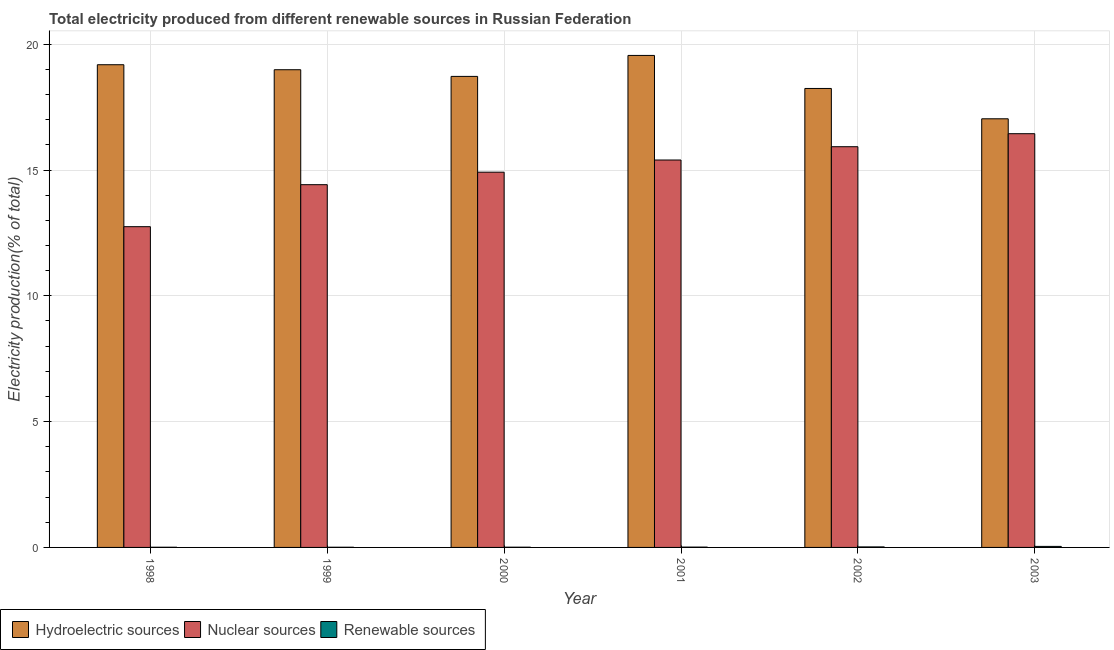How many different coloured bars are there?
Your answer should be very brief. 3. Are the number of bars per tick equal to the number of legend labels?
Your answer should be compact. Yes. How many bars are there on the 6th tick from the left?
Offer a terse response. 3. How many bars are there on the 2nd tick from the right?
Ensure brevity in your answer.  3. What is the percentage of electricity produced by renewable sources in 1999?
Your answer should be compact. 0.01. Across all years, what is the maximum percentage of electricity produced by renewable sources?
Your answer should be very brief. 0.04. Across all years, what is the minimum percentage of electricity produced by nuclear sources?
Ensure brevity in your answer.  12.75. What is the total percentage of electricity produced by hydroelectric sources in the graph?
Give a very brief answer. 111.72. What is the difference between the percentage of electricity produced by nuclear sources in 1998 and that in 2000?
Provide a succinct answer. -2.17. What is the difference between the percentage of electricity produced by renewable sources in 2003 and the percentage of electricity produced by hydroelectric sources in 1998?
Your answer should be compact. 0.03. What is the average percentage of electricity produced by renewable sources per year?
Ensure brevity in your answer.  0.02. In the year 1998, what is the difference between the percentage of electricity produced by nuclear sources and percentage of electricity produced by hydroelectric sources?
Ensure brevity in your answer.  0. In how many years, is the percentage of electricity produced by hydroelectric sources greater than 17 %?
Your answer should be very brief. 6. What is the ratio of the percentage of electricity produced by renewable sources in 1998 to that in 2000?
Make the answer very short. 0.75. What is the difference between the highest and the second highest percentage of electricity produced by hydroelectric sources?
Offer a terse response. 0.37. What is the difference between the highest and the lowest percentage of electricity produced by renewable sources?
Ensure brevity in your answer.  0.03. Is the sum of the percentage of electricity produced by hydroelectric sources in 2001 and 2003 greater than the maximum percentage of electricity produced by renewable sources across all years?
Make the answer very short. Yes. What does the 2nd bar from the left in 2001 represents?
Your response must be concise. Nuclear sources. What does the 1st bar from the right in 2001 represents?
Offer a terse response. Renewable sources. Is it the case that in every year, the sum of the percentage of electricity produced by hydroelectric sources and percentage of electricity produced by nuclear sources is greater than the percentage of electricity produced by renewable sources?
Provide a succinct answer. Yes. Are all the bars in the graph horizontal?
Make the answer very short. No. How many years are there in the graph?
Your answer should be compact. 6. Are the values on the major ticks of Y-axis written in scientific E-notation?
Your answer should be very brief. No. Does the graph contain any zero values?
Your answer should be very brief. No. Does the graph contain grids?
Your answer should be compact. Yes. How many legend labels are there?
Ensure brevity in your answer.  3. How are the legend labels stacked?
Make the answer very short. Horizontal. What is the title of the graph?
Your response must be concise. Total electricity produced from different renewable sources in Russian Federation. Does "Infant(male)" appear as one of the legend labels in the graph?
Keep it short and to the point. No. What is the label or title of the Y-axis?
Give a very brief answer. Electricity production(% of total). What is the Electricity production(% of total) of Hydroelectric sources in 1998?
Make the answer very short. 19.18. What is the Electricity production(% of total) of Nuclear sources in 1998?
Offer a terse response. 12.75. What is the Electricity production(% of total) of Renewable sources in 1998?
Your answer should be very brief. 0.01. What is the Electricity production(% of total) of Hydroelectric sources in 1999?
Your answer should be very brief. 18.99. What is the Electricity production(% of total) in Nuclear sources in 1999?
Give a very brief answer. 14.42. What is the Electricity production(% of total) in Renewable sources in 1999?
Give a very brief answer. 0.01. What is the Electricity production(% of total) of Hydroelectric sources in 2000?
Keep it short and to the point. 18.72. What is the Electricity production(% of total) in Nuclear sources in 2000?
Provide a short and direct response. 14.91. What is the Electricity production(% of total) of Renewable sources in 2000?
Ensure brevity in your answer.  0.01. What is the Electricity production(% of total) in Hydroelectric sources in 2001?
Offer a very short reply. 19.55. What is the Electricity production(% of total) of Nuclear sources in 2001?
Ensure brevity in your answer.  15.4. What is the Electricity production(% of total) in Renewable sources in 2001?
Offer a very short reply. 0.01. What is the Electricity production(% of total) in Hydroelectric sources in 2002?
Offer a terse response. 18.24. What is the Electricity production(% of total) in Nuclear sources in 2002?
Offer a terse response. 15.93. What is the Electricity production(% of total) in Renewable sources in 2002?
Give a very brief answer. 0.02. What is the Electricity production(% of total) in Hydroelectric sources in 2003?
Keep it short and to the point. 17.04. What is the Electricity production(% of total) in Nuclear sources in 2003?
Offer a terse response. 16.44. What is the Electricity production(% of total) of Renewable sources in 2003?
Provide a short and direct response. 0.04. Across all years, what is the maximum Electricity production(% of total) of Hydroelectric sources?
Offer a terse response. 19.55. Across all years, what is the maximum Electricity production(% of total) in Nuclear sources?
Your answer should be compact. 16.44. Across all years, what is the maximum Electricity production(% of total) of Renewable sources?
Your answer should be very brief. 0.04. Across all years, what is the minimum Electricity production(% of total) of Hydroelectric sources?
Ensure brevity in your answer.  17.04. Across all years, what is the minimum Electricity production(% of total) of Nuclear sources?
Your response must be concise. 12.75. Across all years, what is the minimum Electricity production(% of total) in Renewable sources?
Provide a short and direct response. 0.01. What is the total Electricity production(% of total) of Hydroelectric sources in the graph?
Make the answer very short. 111.72. What is the total Electricity production(% of total) in Nuclear sources in the graph?
Provide a succinct answer. 89.84. What is the total Electricity production(% of total) of Renewable sources in the graph?
Make the answer very short. 0.1. What is the difference between the Electricity production(% of total) in Hydroelectric sources in 1998 and that in 1999?
Your answer should be very brief. 0.2. What is the difference between the Electricity production(% of total) of Nuclear sources in 1998 and that in 1999?
Offer a very short reply. -1.67. What is the difference between the Electricity production(% of total) of Renewable sources in 1998 and that in 1999?
Provide a short and direct response. -0. What is the difference between the Electricity production(% of total) of Hydroelectric sources in 1998 and that in 2000?
Keep it short and to the point. 0.46. What is the difference between the Electricity production(% of total) of Nuclear sources in 1998 and that in 2000?
Your answer should be compact. -2.17. What is the difference between the Electricity production(% of total) in Renewable sources in 1998 and that in 2000?
Provide a short and direct response. -0. What is the difference between the Electricity production(% of total) in Hydroelectric sources in 1998 and that in 2001?
Your response must be concise. -0.37. What is the difference between the Electricity production(% of total) in Nuclear sources in 1998 and that in 2001?
Give a very brief answer. -2.65. What is the difference between the Electricity production(% of total) of Renewable sources in 1998 and that in 2001?
Give a very brief answer. -0.01. What is the difference between the Electricity production(% of total) in Hydroelectric sources in 1998 and that in 2002?
Provide a succinct answer. 0.94. What is the difference between the Electricity production(% of total) of Nuclear sources in 1998 and that in 2002?
Ensure brevity in your answer.  -3.18. What is the difference between the Electricity production(% of total) of Renewable sources in 1998 and that in 2002?
Offer a terse response. -0.01. What is the difference between the Electricity production(% of total) in Hydroelectric sources in 1998 and that in 2003?
Your response must be concise. 2.15. What is the difference between the Electricity production(% of total) in Nuclear sources in 1998 and that in 2003?
Your answer should be compact. -3.7. What is the difference between the Electricity production(% of total) of Renewable sources in 1998 and that in 2003?
Your answer should be compact. -0.03. What is the difference between the Electricity production(% of total) in Hydroelectric sources in 1999 and that in 2000?
Offer a terse response. 0.27. What is the difference between the Electricity production(% of total) in Nuclear sources in 1999 and that in 2000?
Keep it short and to the point. -0.5. What is the difference between the Electricity production(% of total) of Renewable sources in 1999 and that in 2000?
Your answer should be very brief. -0. What is the difference between the Electricity production(% of total) in Hydroelectric sources in 1999 and that in 2001?
Your answer should be very brief. -0.57. What is the difference between the Electricity production(% of total) in Nuclear sources in 1999 and that in 2001?
Your answer should be very brief. -0.98. What is the difference between the Electricity production(% of total) of Renewable sources in 1999 and that in 2001?
Offer a very short reply. -0.01. What is the difference between the Electricity production(% of total) of Hydroelectric sources in 1999 and that in 2002?
Keep it short and to the point. 0.74. What is the difference between the Electricity production(% of total) in Nuclear sources in 1999 and that in 2002?
Provide a succinct answer. -1.51. What is the difference between the Electricity production(% of total) in Renewable sources in 1999 and that in 2002?
Your answer should be very brief. -0.01. What is the difference between the Electricity production(% of total) in Hydroelectric sources in 1999 and that in 2003?
Provide a succinct answer. 1.95. What is the difference between the Electricity production(% of total) in Nuclear sources in 1999 and that in 2003?
Make the answer very short. -2.03. What is the difference between the Electricity production(% of total) of Renewable sources in 1999 and that in 2003?
Ensure brevity in your answer.  -0.03. What is the difference between the Electricity production(% of total) in Hydroelectric sources in 2000 and that in 2001?
Your answer should be very brief. -0.83. What is the difference between the Electricity production(% of total) of Nuclear sources in 2000 and that in 2001?
Provide a succinct answer. -0.48. What is the difference between the Electricity production(% of total) of Renewable sources in 2000 and that in 2001?
Keep it short and to the point. -0. What is the difference between the Electricity production(% of total) in Hydroelectric sources in 2000 and that in 2002?
Provide a succinct answer. 0.48. What is the difference between the Electricity production(% of total) of Nuclear sources in 2000 and that in 2002?
Your answer should be very brief. -1.01. What is the difference between the Electricity production(% of total) in Renewable sources in 2000 and that in 2002?
Provide a succinct answer. -0.01. What is the difference between the Electricity production(% of total) in Hydroelectric sources in 2000 and that in 2003?
Provide a short and direct response. 1.68. What is the difference between the Electricity production(% of total) in Nuclear sources in 2000 and that in 2003?
Make the answer very short. -1.53. What is the difference between the Electricity production(% of total) in Renewable sources in 2000 and that in 2003?
Your answer should be very brief. -0.03. What is the difference between the Electricity production(% of total) in Hydroelectric sources in 2001 and that in 2002?
Provide a succinct answer. 1.31. What is the difference between the Electricity production(% of total) of Nuclear sources in 2001 and that in 2002?
Offer a very short reply. -0.53. What is the difference between the Electricity production(% of total) in Renewable sources in 2001 and that in 2002?
Your answer should be very brief. -0.01. What is the difference between the Electricity production(% of total) of Hydroelectric sources in 2001 and that in 2003?
Provide a short and direct response. 2.52. What is the difference between the Electricity production(% of total) in Nuclear sources in 2001 and that in 2003?
Offer a terse response. -1.05. What is the difference between the Electricity production(% of total) in Renewable sources in 2001 and that in 2003?
Make the answer very short. -0.03. What is the difference between the Electricity production(% of total) of Hydroelectric sources in 2002 and that in 2003?
Provide a short and direct response. 1.21. What is the difference between the Electricity production(% of total) in Nuclear sources in 2002 and that in 2003?
Give a very brief answer. -0.52. What is the difference between the Electricity production(% of total) of Renewable sources in 2002 and that in 2003?
Give a very brief answer. -0.02. What is the difference between the Electricity production(% of total) of Hydroelectric sources in 1998 and the Electricity production(% of total) of Nuclear sources in 1999?
Provide a short and direct response. 4.77. What is the difference between the Electricity production(% of total) in Hydroelectric sources in 1998 and the Electricity production(% of total) in Renewable sources in 1999?
Your answer should be compact. 19.18. What is the difference between the Electricity production(% of total) of Nuclear sources in 1998 and the Electricity production(% of total) of Renewable sources in 1999?
Offer a very short reply. 12.74. What is the difference between the Electricity production(% of total) of Hydroelectric sources in 1998 and the Electricity production(% of total) of Nuclear sources in 2000?
Your response must be concise. 4.27. What is the difference between the Electricity production(% of total) in Hydroelectric sources in 1998 and the Electricity production(% of total) in Renewable sources in 2000?
Your answer should be very brief. 19.17. What is the difference between the Electricity production(% of total) in Nuclear sources in 1998 and the Electricity production(% of total) in Renewable sources in 2000?
Your answer should be compact. 12.74. What is the difference between the Electricity production(% of total) in Hydroelectric sources in 1998 and the Electricity production(% of total) in Nuclear sources in 2001?
Give a very brief answer. 3.79. What is the difference between the Electricity production(% of total) of Hydroelectric sources in 1998 and the Electricity production(% of total) of Renewable sources in 2001?
Give a very brief answer. 19.17. What is the difference between the Electricity production(% of total) of Nuclear sources in 1998 and the Electricity production(% of total) of Renewable sources in 2001?
Provide a succinct answer. 12.73. What is the difference between the Electricity production(% of total) of Hydroelectric sources in 1998 and the Electricity production(% of total) of Nuclear sources in 2002?
Give a very brief answer. 3.26. What is the difference between the Electricity production(% of total) of Hydroelectric sources in 1998 and the Electricity production(% of total) of Renewable sources in 2002?
Give a very brief answer. 19.16. What is the difference between the Electricity production(% of total) of Nuclear sources in 1998 and the Electricity production(% of total) of Renewable sources in 2002?
Give a very brief answer. 12.73. What is the difference between the Electricity production(% of total) of Hydroelectric sources in 1998 and the Electricity production(% of total) of Nuclear sources in 2003?
Your response must be concise. 2.74. What is the difference between the Electricity production(% of total) of Hydroelectric sources in 1998 and the Electricity production(% of total) of Renewable sources in 2003?
Ensure brevity in your answer.  19.14. What is the difference between the Electricity production(% of total) in Nuclear sources in 1998 and the Electricity production(% of total) in Renewable sources in 2003?
Ensure brevity in your answer.  12.71. What is the difference between the Electricity production(% of total) of Hydroelectric sources in 1999 and the Electricity production(% of total) of Nuclear sources in 2000?
Offer a terse response. 4.07. What is the difference between the Electricity production(% of total) of Hydroelectric sources in 1999 and the Electricity production(% of total) of Renewable sources in 2000?
Make the answer very short. 18.98. What is the difference between the Electricity production(% of total) of Nuclear sources in 1999 and the Electricity production(% of total) of Renewable sources in 2000?
Give a very brief answer. 14.41. What is the difference between the Electricity production(% of total) of Hydroelectric sources in 1999 and the Electricity production(% of total) of Nuclear sources in 2001?
Give a very brief answer. 3.59. What is the difference between the Electricity production(% of total) of Hydroelectric sources in 1999 and the Electricity production(% of total) of Renewable sources in 2001?
Give a very brief answer. 18.97. What is the difference between the Electricity production(% of total) of Nuclear sources in 1999 and the Electricity production(% of total) of Renewable sources in 2001?
Provide a short and direct response. 14.4. What is the difference between the Electricity production(% of total) in Hydroelectric sources in 1999 and the Electricity production(% of total) in Nuclear sources in 2002?
Keep it short and to the point. 3.06. What is the difference between the Electricity production(% of total) of Hydroelectric sources in 1999 and the Electricity production(% of total) of Renewable sources in 2002?
Your answer should be very brief. 18.97. What is the difference between the Electricity production(% of total) of Nuclear sources in 1999 and the Electricity production(% of total) of Renewable sources in 2002?
Provide a succinct answer. 14.4. What is the difference between the Electricity production(% of total) of Hydroelectric sources in 1999 and the Electricity production(% of total) of Nuclear sources in 2003?
Make the answer very short. 2.54. What is the difference between the Electricity production(% of total) in Hydroelectric sources in 1999 and the Electricity production(% of total) in Renewable sources in 2003?
Your answer should be very brief. 18.94. What is the difference between the Electricity production(% of total) of Nuclear sources in 1999 and the Electricity production(% of total) of Renewable sources in 2003?
Your answer should be compact. 14.38. What is the difference between the Electricity production(% of total) of Hydroelectric sources in 2000 and the Electricity production(% of total) of Nuclear sources in 2001?
Keep it short and to the point. 3.32. What is the difference between the Electricity production(% of total) of Hydroelectric sources in 2000 and the Electricity production(% of total) of Renewable sources in 2001?
Give a very brief answer. 18.71. What is the difference between the Electricity production(% of total) in Nuclear sources in 2000 and the Electricity production(% of total) in Renewable sources in 2001?
Make the answer very short. 14.9. What is the difference between the Electricity production(% of total) in Hydroelectric sources in 2000 and the Electricity production(% of total) in Nuclear sources in 2002?
Give a very brief answer. 2.79. What is the difference between the Electricity production(% of total) of Hydroelectric sources in 2000 and the Electricity production(% of total) of Renewable sources in 2002?
Offer a terse response. 18.7. What is the difference between the Electricity production(% of total) in Nuclear sources in 2000 and the Electricity production(% of total) in Renewable sources in 2002?
Make the answer very short. 14.89. What is the difference between the Electricity production(% of total) in Hydroelectric sources in 2000 and the Electricity production(% of total) in Nuclear sources in 2003?
Provide a succinct answer. 2.28. What is the difference between the Electricity production(% of total) in Hydroelectric sources in 2000 and the Electricity production(% of total) in Renewable sources in 2003?
Your answer should be compact. 18.68. What is the difference between the Electricity production(% of total) of Nuclear sources in 2000 and the Electricity production(% of total) of Renewable sources in 2003?
Your response must be concise. 14.87. What is the difference between the Electricity production(% of total) of Hydroelectric sources in 2001 and the Electricity production(% of total) of Nuclear sources in 2002?
Make the answer very short. 3.63. What is the difference between the Electricity production(% of total) of Hydroelectric sources in 2001 and the Electricity production(% of total) of Renewable sources in 2002?
Make the answer very short. 19.53. What is the difference between the Electricity production(% of total) in Nuclear sources in 2001 and the Electricity production(% of total) in Renewable sources in 2002?
Your answer should be compact. 15.38. What is the difference between the Electricity production(% of total) in Hydroelectric sources in 2001 and the Electricity production(% of total) in Nuclear sources in 2003?
Offer a very short reply. 3.11. What is the difference between the Electricity production(% of total) of Hydroelectric sources in 2001 and the Electricity production(% of total) of Renewable sources in 2003?
Keep it short and to the point. 19.51. What is the difference between the Electricity production(% of total) of Nuclear sources in 2001 and the Electricity production(% of total) of Renewable sources in 2003?
Offer a terse response. 15.36. What is the difference between the Electricity production(% of total) of Hydroelectric sources in 2002 and the Electricity production(% of total) of Nuclear sources in 2003?
Ensure brevity in your answer.  1.8. What is the difference between the Electricity production(% of total) of Hydroelectric sources in 2002 and the Electricity production(% of total) of Renewable sources in 2003?
Offer a terse response. 18.2. What is the difference between the Electricity production(% of total) in Nuclear sources in 2002 and the Electricity production(% of total) in Renewable sources in 2003?
Ensure brevity in your answer.  15.88. What is the average Electricity production(% of total) of Hydroelectric sources per year?
Your response must be concise. 18.62. What is the average Electricity production(% of total) in Nuclear sources per year?
Make the answer very short. 14.97. What is the average Electricity production(% of total) of Renewable sources per year?
Keep it short and to the point. 0.02. In the year 1998, what is the difference between the Electricity production(% of total) in Hydroelectric sources and Electricity production(% of total) in Nuclear sources?
Your answer should be compact. 6.44. In the year 1998, what is the difference between the Electricity production(% of total) in Hydroelectric sources and Electricity production(% of total) in Renewable sources?
Keep it short and to the point. 19.18. In the year 1998, what is the difference between the Electricity production(% of total) in Nuclear sources and Electricity production(% of total) in Renewable sources?
Give a very brief answer. 12.74. In the year 1999, what is the difference between the Electricity production(% of total) of Hydroelectric sources and Electricity production(% of total) of Nuclear sources?
Provide a succinct answer. 4.57. In the year 1999, what is the difference between the Electricity production(% of total) of Hydroelectric sources and Electricity production(% of total) of Renewable sources?
Your answer should be compact. 18.98. In the year 1999, what is the difference between the Electricity production(% of total) of Nuclear sources and Electricity production(% of total) of Renewable sources?
Provide a succinct answer. 14.41. In the year 2000, what is the difference between the Electricity production(% of total) of Hydroelectric sources and Electricity production(% of total) of Nuclear sources?
Offer a very short reply. 3.81. In the year 2000, what is the difference between the Electricity production(% of total) in Hydroelectric sources and Electricity production(% of total) in Renewable sources?
Offer a very short reply. 18.71. In the year 2000, what is the difference between the Electricity production(% of total) of Nuclear sources and Electricity production(% of total) of Renewable sources?
Keep it short and to the point. 14.9. In the year 2001, what is the difference between the Electricity production(% of total) of Hydroelectric sources and Electricity production(% of total) of Nuclear sources?
Give a very brief answer. 4.16. In the year 2001, what is the difference between the Electricity production(% of total) in Hydroelectric sources and Electricity production(% of total) in Renewable sources?
Your answer should be compact. 19.54. In the year 2001, what is the difference between the Electricity production(% of total) of Nuclear sources and Electricity production(% of total) of Renewable sources?
Provide a short and direct response. 15.38. In the year 2002, what is the difference between the Electricity production(% of total) of Hydroelectric sources and Electricity production(% of total) of Nuclear sources?
Your answer should be very brief. 2.31. In the year 2002, what is the difference between the Electricity production(% of total) of Hydroelectric sources and Electricity production(% of total) of Renewable sources?
Ensure brevity in your answer.  18.22. In the year 2002, what is the difference between the Electricity production(% of total) of Nuclear sources and Electricity production(% of total) of Renewable sources?
Ensure brevity in your answer.  15.91. In the year 2003, what is the difference between the Electricity production(% of total) of Hydroelectric sources and Electricity production(% of total) of Nuclear sources?
Offer a terse response. 0.59. In the year 2003, what is the difference between the Electricity production(% of total) in Hydroelectric sources and Electricity production(% of total) in Renewable sources?
Offer a terse response. 16.99. In the year 2003, what is the difference between the Electricity production(% of total) in Nuclear sources and Electricity production(% of total) in Renewable sources?
Offer a terse response. 16.4. What is the ratio of the Electricity production(% of total) of Hydroelectric sources in 1998 to that in 1999?
Ensure brevity in your answer.  1.01. What is the ratio of the Electricity production(% of total) in Nuclear sources in 1998 to that in 1999?
Ensure brevity in your answer.  0.88. What is the ratio of the Electricity production(% of total) of Renewable sources in 1998 to that in 1999?
Provide a succinct answer. 0.99. What is the ratio of the Electricity production(% of total) of Hydroelectric sources in 1998 to that in 2000?
Offer a terse response. 1.02. What is the ratio of the Electricity production(% of total) in Nuclear sources in 1998 to that in 2000?
Your response must be concise. 0.85. What is the ratio of the Electricity production(% of total) of Renewable sources in 1998 to that in 2000?
Your answer should be very brief. 0.75. What is the ratio of the Electricity production(% of total) of Hydroelectric sources in 1998 to that in 2001?
Your response must be concise. 0.98. What is the ratio of the Electricity production(% of total) of Nuclear sources in 1998 to that in 2001?
Provide a short and direct response. 0.83. What is the ratio of the Electricity production(% of total) in Renewable sources in 1998 to that in 2001?
Offer a very short reply. 0.53. What is the ratio of the Electricity production(% of total) in Hydroelectric sources in 1998 to that in 2002?
Keep it short and to the point. 1.05. What is the ratio of the Electricity production(% of total) of Nuclear sources in 1998 to that in 2002?
Provide a succinct answer. 0.8. What is the ratio of the Electricity production(% of total) of Renewable sources in 1998 to that in 2002?
Give a very brief answer. 0.35. What is the ratio of the Electricity production(% of total) of Hydroelectric sources in 1998 to that in 2003?
Your answer should be compact. 1.13. What is the ratio of the Electricity production(% of total) in Nuclear sources in 1998 to that in 2003?
Your response must be concise. 0.78. What is the ratio of the Electricity production(% of total) in Renewable sources in 1998 to that in 2003?
Offer a very short reply. 0.17. What is the ratio of the Electricity production(% of total) in Hydroelectric sources in 1999 to that in 2000?
Offer a very short reply. 1.01. What is the ratio of the Electricity production(% of total) of Nuclear sources in 1999 to that in 2000?
Make the answer very short. 0.97. What is the ratio of the Electricity production(% of total) of Renewable sources in 1999 to that in 2000?
Keep it short and to the point. 0.76. What is the ratio of the Electricity production(% of total) of Hydroelectric sources in 1999 to that in 2001?
Give a very brief answer. 0.97. What is the ratio of the Electricity production(% of total) in Nuclear sources in 1999 to that in 2001?
Keep it short and to the point. 0.94. What is the ratio of the Electricity production(% of total) in Renewable sources in 1999 to that in 2001?
Your response must be concise. 0.54. What is the ratio of the Electricity production(% of total) of Hydroelectric sources in 1999 to that in 2002?
Provide a succinct answer. 1.04. What is the ratio of the Electricity production(% of total) of Nuclear sources in 1999 to that in 2002?
Provide a succinct answer. 0.91. What is the ratio of the Electricity production(% of total) of Renewable sources in 1999 to that in 2002?
Your answer should be very brief. 0.35. What is the ratio of the Electricity production(% of total) of Hydroelectric sources in 1999 to that in 2003?
Offer a very short reply. 1.11. What is the ratio of the Electricity production(% of total) in Nuclear sources in 1999 to that in 2003?
Offer a very short reply. 0.88. What is the ratio of the Electricity production(% of total) of Renewable sources in 1999 to that in 2003?
Your answer should be compact. 0.17. What is the ratio of the Electricity production(% of total) of Hydroelectric sources in 2000 to that in 2001?
Offer a very short reply. 0.96. What is the ratio of the Electricity production(% of total) of Nuclear sources in 2000 to that in 2001?
Your response must be concise. 0.97. What is the ratio of the Electricity production(% of total) in Renewable sources in 2000 to that in 2001?
Your answer should be compact. 0.71. What is the ratio of the Electricity production(% of total) of Hydroelectric sources in 2000 to that in 2002?
Your answer should be very brief. 1.03. What is the ratio of the Electricity production(% of total) of Nuclear sources in 2000 to that in 2002?
Ensure brevity in your answer.  0.94. What is the ratio of the Electricity production(% of total) of Renewable sources in 2000 to that in 2002?
Offer a terse response. 0.46. What is the ratio of the Electricity production(% of total) of Hydroelectric sources in 2000 to that in 2003?
Offer a very short reply. 1.1. What is the ratio of the Electricity production(% of total) in Nuclear sources in 2000 to that in 2003?
Provide a succinct answer. 0.91. What is the ratio of the Electricity production(% of total) of Renewable sources in 2000 to that in 2003?
Your response must be concise. 0.23. What is the ratio of the Electricity production(% of total) in Hydroelectric sources in 2001 to that in 2002?
Offer a terse response. 1.07. What is the ratio of the Electricity production(% of total) of Nuclear sources in 2001 to that in 2002?
Keep it short and to the point. 0.97. What is the ratio of the Electricity production(% of total) of Renewable sources in 2001 to that in 2002?
Your response must be concise. 0.65. What is the ratio of the Electricity production(% of total) in Hydroelectric sources in 2001 to that in 2003?
Offer a very short reply. 1.15. What is the ratio of the Electricity production(% of total) of Nuclear sources in 2001 to that in 2003?
Your response must be concise. 0.94. What is the ratio of the Electricity production(% of total) of Renewable sources in 2001 to that in 2003?
Offer a very short reply. 0.32. What is the ratio of the Electricity production(% of total) of Hydroelectric sources in 2002 to that in 2003?
Keep it short and to the point. 1.07. What is the ratio of the Electricity production(% of total) of Nuclear sources in 2002 to that in 2003?
Make the answer very short. 0.97. What is the ratio of the Electricity production(% of total) of Renewable sources in 2002 to that in 2003?
Provide a short and direct response. 0.49. What is the difference between the highest and the second highest Electricity production(% of total) of Hydroelectric sources?
Your answer should be very brief. 0.37. What is the difference between the highest and the second highest Electricity production(% of total) in Nuclear sources?
Offer a terse response. 0.52. What is the difference between the highest and the second highest Electricity production(% of total) in Renewable sources?
Give a very brief answer. 0.02. What is the difference between the highest and the lowest Electricity production(% of total) in Hydroelectric sources?
Keep it short and to the point. 2.52. What is the difference between the highest and the lowest Electricity production(% of total) in Nuclear sources?
Your answer should be very brief. 3.7. What is the difference between the highest and the lowest Electricity production(% of total) in Renewable sources?
Offer a terse response. 0.03. 